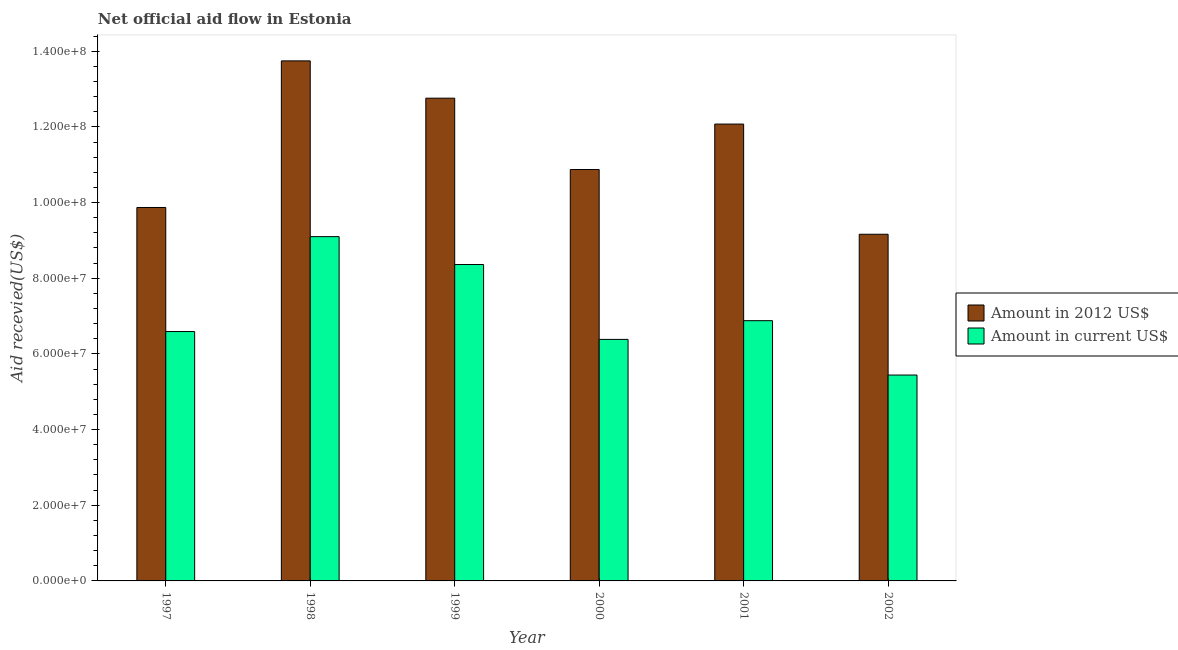How many groups of bars are there?
Offer a very short reply. 6. Are the number of bars on each tick of the X-axis equal?
Ensure brevity in your answer.  Yes. How many bars are there on the 1st tick from the right?
Your response must be concise. 2. What is the amount of aid received(expressed in 2012 us$) in 2002?
Make the answer very short. 9.16e+07. Across all years, what is the maximum amount of aid received(expressed in us$)?
Ensure brevity in your answer.  9.10e+07. Across all years, what is the minimum amount of aid received(expressed in 2012 us$)?
Ensure brevity in your answer.  9.16e+07. In which year was the amount of aid received(expressed in us$) maximum?
Provide a succinct answer. 1998. What is the total amount of aid received(expressed in 2012 us$) in the graph?
Offer a terse response. 6.85e+08. What is the difference between the amount of aid received(expressed in 2012 us$) in 2000 and that in 2001?
Offer a very short reply. -1.20e+07. What is the difference between the amount of aid received(expressed in 2012 us$) in 1997 and the amount of aid received(expressed in us$) in 2001?
Offer a very short reply. -2.20e+07. What is the average amount of aid received(expressed in 2012 us$) per year?
Your response must be concise. 1.14e+08. In how many years, is the amount of aid received(expressed in 2012 us$) greater than 112000000 US$?
Your answer should be compact. 3. What is the ratio of the amount of aid received(expressed in 2012 us$) in 1997 to that in 1999?
Provide a succinct answer. 0.77. Is the amount of aid received(expressed in 2012 us$) in 1999 less than that in 2002?
Give a very brief answer. No. Is the difference between the amount of aid received(expressed in us$) in 1999 and 2001 greater than the difference between the amount of aid received(expressed in 2012 us$) in 1999 and 2001?
Provide a short and direct response. No. What is the difference between the highest and the second highest amount of aid received(expressed in 2012 us$)?
Provide a succinct answer. 9.86e+06. What is the difference between the highest and the lowest amount of aid received(expressed in 2012 us$)?
Give a very brief answer. 4.58e+07. What does the 1st bar from the left in 2000 represents?
Your answer should be compact. Amount in 2012 US$. What does the 2nd bar from the right in 1997 represents?
Your response must be concise. Amount in 2012 US$. Are all the bars in the graph horizontal?
Your response must be concise. No. How many years are there in the graph?
Offer a terse response. 6. Are the values on the major ticks of Y-axis written in scientific E-notation?
Give a very brief answer. Yes. Does the graph contain any zero values?
Offer a terse response. No. What is the title of the graph?
Provide a short and direct response. Net official aid flow in Estonia. Does "Mobile cellular" appear as one of the legend labels in the graph?
Provide a short and direct response. No. What is the label or title of the Y-axis?
Ensure brevity in your answer.  Aid recevied(US$). What is the Aid recevied(US$) in Amount in 2012 US$ in 1997?
Make the answer very short. 9.87e+07. What is the Aid recevied(US$) in Amount in current US$ in 1997?
Ensure brevity in your answer.  6.59e+07. What is the Aid recevied(US$) of Amount in 2012 US$ in 1998?
Provide a succinct answer. 1.37e+08. What is the Aid recevied(US$) in Amount in current US$ in 1998?
Your answer should be compact. 9.10e+07. What is the Aid recevied(US$) in Amount in 2012 US$ in 1999?
Provide a short and direct response. 1.28e+08. What is the Aid recevied(US$) in Amount in current US$ in 1999?
Provide a succinct answer. 8.36e+07. What is the Aid recevied(US$) of Amount in 2012 US$ in 2000?
Your response must be concise. 1.09e+08. What is the Aid recevied(US$) in Amount in current US$ in 2000?
Provide a short and direct response. 6.38e+07. What is the Aid recevied(US$) in Amount in 2012 US$ in 2001?
Give a very brief answer. 1.21e+08. What is the Aid recevied(US$) in Amount in current US$ in 2001?
Your answer should be compact. 6.88e+07. What is the Aid recevied(US$) in Amount in 2012 US$ in 2002?
Your response must be concise. 9.16e+07. What is the Aid recevied(US$) of Amount in current US$ in 2002?
Give a very brief answer. 5.44e+07. Across all years, what is the maximum Aid recevied(US$) in Amount in 2012 US$?
Provide a short and direct response. 1.37e+08. Across all years, what is the maximum Aid recevied(US$) of Amount in current US$?
Your response must be concise. 9.10e+07. Across all years, what is the minimum Aid recevied(US$) of Amount in 2012 US$?
Offer a very short reply. 9.16e+07. Across all years, what is the minimum Aid recevied(US$) of Amount in current US$?
Provide a short and direct response. 5.44e+07. What is the total Aid recevied(US$) of Amount in 2012 US$ in the graph?
Provide a short and direct response. 6.85e+08. What is the total Aid recevied(US$) of Amount in current US$ in the graph?
Keep it short and to the point. 4.28e+08. What is the difference between the Aid recevied(US$) in Amount in 2012 US$ in 1997 and that in 1998?
Offer a very short reply. -3.88e+07. What is the difference between the Aid recevied(US$) of Amount in current US$ in 1997 and that in 1998?
Provide a short and direct response. -2.51e+07. What is the difference between the Aid recevied(US$) in Amount in 2012 US$ in 1997 and that in 1999?
Your response must be concise. -2.89e+07. What is the difference between the Aid recevied(US$) in Amount in current US$ in 1997 and that in 1999?
Keep it short and to the point. -1.77e+07. What is the difference between the Aid recevied(US$) in Amount in 2012 US$ in 1997 and that in 2000?
Offer a terse response. -1.00e+07. What is the difference between the Aid recevied(US$) in Amount in current US$ in 1997 and that in 2000?
Give a very brief answer. 2.08e+06. What is the difference between the Aid recevied(US$) of Amount in 2012 US$ in 1997 and that in 2001?
Offer a terse response. -2.20e+07. What is the difference between the Aid recevied(US$) in Amount in current US$ in 1997 and that in 2001?
Your answer should be compact. -2.87e+06. What is the difference between the Aid recevied(US$) in Amount in 2012 US$ in 1997 and that in 2002?
Ensure brevity in your answer.  7.07e+06. What is the difference between the Aid recevied(US$) in Amount in current US$ in 1997 and that in 2002?
Offer a terse response. 1.15e+07. What is the difference between the Aid recevied(US$) in Amount in 2012 US$ in 1998 and that in 1999?
Offer a terse response. 9.86e+06. What is the difference between the Aid recevied(US$) in Amount in current US$ in 1998 and that in 1999?
Your response must be concise. 7.37e+06. What is the difference between the Aid recevied(US$) of Amount in 2012 US$ in 1998 and that in 2000?
Provide a short and direct response. 2.87e+07. What is the difference between the Aid recevied(US$) of Amount in current US$ in 1998 and that in 2000?
Provide a succinct answer. 2.72e+07. What is the difference between the Aid recevied(US$) in Amount in 2012 US$ in 1998 and that in 2001?
Provide a succinct answer. 1.67e+07. What is the difference between the Aid recevied(US$) of Amount in current US$ in 1998 and that in 2001?
Keep it short and to the point. 2.22e+07. What is the difference between the Aid recevied(US$) of Amount in 2012 US$ in 1998 and that in 2002?
Make the answer very short. 4.58e+07. What is the difference between the Aid recevied(US$) in Amount in current US$ in 1998 and that in 2002?
Provide a succinct answer. 3.66e+07. What is the difference between the Aid recevied(US$) in Amount in 2012 US$ in 1999 and that in 2000?
Provide a succinct answer. 1.88e+07. What is the difference between the Aid recevied(US$) in Amount in current US$ in 1999 and that in 2000?
Ensure brevity in your answer.  1.98e+07. What is the difference between the Aid recevied(US$) of Amount in 2012 US$ in 1999 and that in 2001?
Your response must be concise. 6.84e+06. What is the difference between the Aid recevied(US$) in Amount in current US$ in 1999 and that in 2001?
Ensure brevity in your answer.  1.48e+07. What is the difference between the Aid recevied(US$) of Amount in 2012 US$ in 1999 and that in 2002?
Give a very brief answer. 3.60e+07. What is the difference between the Aid recevied(US$) in Amount in current US$ in 1999 and that in 2002?
Your response must be concise. 2.92e+07. What is the difference between the Aid recevied(US$) in Amount in 2012 US$ in 2000 and that in 2001?
Your response must be concise. -1.20e+07. What is the difference between the Aid recevied(US$) in Amount in current US$ in 2000 and that in 2001?
Provide a succinct answer. -4.95e+06. What is the difference between the Aid recevied(US$) in Amount in 2012 US$ in 2000 and that in 2002?
Give a very brief answer. 1.71e+07. What is the difference between the Aid recevied(US$) of Amount in current US$ in 2000 and that in 2002?
Offer a very short reply. 9.42e+06. What is the difference between the Aid recevied(US$) of Amount in 2012 US$ in 2001 and that in 2002?
Ensure brevity in your answer.  2.91e+07. What is the difference between the Aid recevied(US$) of Amount in current US$ in 2001 and that in 2002?
Keep it short and to the point. 1.44e+07. What is the difference between the Aid recevied(US$) of Amount in 2012 US$ in 1997 and the Aid recevied(US$) of Amount in current US$ in 1998?
Offer a terse response. 7.70e+06. What is the difference between the Aid recevied(US$) in Amount in 2012 US$ in 1997 and the Aid recevied(US$) in Amount in current US$ in 1999?
Your answer should be compact. 1.51e+07. What is the difference between the Aid recevied(US$) in Amount in 2012 US$ in 1997 and the Aid recevied(US$) in Amount in current US$ in 2000?
Keep it short and to the point. 3.49e+07. What is the difference between the Aid recevied(US$) in Amount in 2012 US$ in 1997 and the Aid recevied(US$) in Amount in current US$ in 2001?
Offer a very short reply. 2.99e+07. What is the difference between the Aid recevied(US$) in Amount in 2012 US$ in 1997 and the Aid recevied(US$) in Amount in current US$ in 2002?
Your response must be concise. 4.43e+07. What is the difference between the Aid recevied(US$) in Amount in 2012 US$ in 1998 and the Aid recevied(US$) in Amount in current US$ in 1999?
Keep it short and to the point. 5.38e+07. What is the difference between the Aid recevied(US$) of Amount in 2012 US$ in 1998 and the Aid recevied(US$) of Amount in current US$ in 2000?
Provide a short and direct response. 7.36e+07. What is the difference between the Aid recevied(US$) of Amount in 2012 US$ in 1998 and the Aid recevied(US$) of Amount in current US$ in 2001?
Your answer should be compact. 6.87e+07. What is the difference between the Aid recevied(US$) in Amount in 2012 US$ in 1998 and the Aid recevied(US$) in Amount in current US$ in 2002?
Offer a very short reply. 8.30e+07. What is the difference between the Aid recevied(US$) of Amount in 2012 US$ in 1999 and the Aid recevied(US$) of Amount in current US$ in 2000?
Your response must be concise. 6.38e+07. What is the difference between the Aid recevied(US$) of Amount in 2012 US$ in 1999 and the Aid recevied(US$) of Amount in current US$ in 2001?
Keep it short and to the point. 5.88e+07. What is the difference between the Aid recevied(US$) of Amount in 2012 US$ in 1999 and the Aid recevied(US$) of Amount in current US$ in 2002?
Ensure brevity in your answer.  7.32e+07. What is the difference between the Aid recevied(US$) of Amount in 2012 US$ in 2000 and the Aid recevied(US$) of Amount in current US$ in 2001?
Give a very brief answer. 4.00e+07. What is the difference between the Aid recevied(US$) of Amount in 2012 US$ in 2000 and the Aid recevied(US$) of Amount in current US$ in 2002?
Your answer should be compact. 5.43e+07. What is the difference between the Aid recevied(US$) in Amount in 2012 US$ in 2001 and the Aid recevied(US$) in Amount in current US$ in 2002?
Your answer should be very brief. 6.63e+07. What is the average Aid recevied(US$) of Amount in 2012 US$ per year?
Provide a short and direct response. 1.14e+08. What is the average Aid recevied(US$) of Amount in current US$ per year?
Give a very brief answer. 7.13e+07. In the year 1997, what is the difference between the Aid recevied(US$) of Amount in 2012 US$ and Aid recevied(US$) of Amount in current US$?
Offer a terse response. 3.28e+07. In the year 1998, what is the difference between the Aid recevied(US$) of Amount in 2012 US$ and Aid recevied(US$) of Amount in current US$?
Offer a very short reply. 4.64e+07. In the year 1999, what is the difference between the Aid recevied(US$) of Amount in 2012 US$ and Aid recevied(US$) of Amount in current US$?
Ensure brevity in your answer.  4.40e+07. In the year 2000, what is the difference between the Aid recevied(US$) in Amount in 2012 US$ and Aid recevied(US$) in Amount in current US$?
Offer a terse response. 4.49e+07. In the year 2001, what is the difference between the Aid recevied(US$) of Amount in 2012 US$ and Aid recevied(US$) of Amount in current US$?
Offer a very short reply. 5.20e+07. In the year 2002, what is the difference between the Aid recevied(US$) of Amount in 2012 US$ and Aid recevied(US$) of Amount in current US$?
Provide a succinct answer. 3.72e+07. What is the ratio of the Aid recevied(US$) in Amount in 2012 US$ in 1997 to that in 1998?
Offer a very short reply. 0.72. What is the ratio of the Aid recevied(US$) of Amount in current US$ in 1997 to that in 1998?
Offer a very short reply. 0.72. What is the ratio of the Aid recevied(US$) in Amount in 2012 US$ in 1997 to that in 1999?
Offer a terse response. 0.77. What is the ratio of the Aid recevied(US$) in Amount in current US$ in 1997 to that in 1999?
Ensure brevity in your answer.  0.79. What is the ratio of the Aid recevied(US$) in Amount in 2012 US$ in 1997 to that in 2000?
Make the answer very short. 0.91. What is the ratio of the Aid recevied(US$) of Amount in current US$ in 1997 to that in 2000?
Give a very brief answer. 1.03. What is the ratio of the Aid recevied(US$) of Amount in 2012 US$ in 1997 to that in 2001?
Ensure brevity in your answer.  0.82. What is the ratio of the Aid recevied(US$) of Amount in 2012 US$ in 1997 to that in 2002?
Offer a terse response. 1.08. What is the ratio of the Aid recevied(US$) of Amount in current US$ in 1997 to that in 2002?
Your response must be concise. 1.21. What is the ratio of the Aid recevied(US$) of Amount in 2012 US$ in 1998 to that in 1999?
Provide a short and direct response. 1.08. What is the ratio of the Aid recevied(US$) in Amount in current US$ in 1998 to that in 1999?
Make the answer very short. 1.09. What is the ratio of the Aid recevied(US$) in Amount in 2012 US$ in 1998 to that in 2000?
Offer a very short reply. 1.26. What is the ratio of the Aid recevied(US$) in Amount in current US$ in 1998 to that in 2000?
Your response must be concise. 1.43. What is the ratio of the Aid recevied(US$) of Amount in 2012 US$ in 1998 to that in 2001?
Your response must be concise. 1.14. What is the ratio of the Aid recevied(US$) of Amount in current US$ in 1998 to that in 2001?
Offer a very short reply. 1.32. What is the ratio of the Aid recevied(US$) of Amount in 2012 US$ in 1998 to that in 2002?
Offer a terse response. 1.5. What is the ratio of the Aid recevied(US$) of Amount in current US$ in 1998 to that in 2002?
Offer a very short reply. 1.67. What is the ratio of the Aid recevied(US$) in Amount in 2012 US$ in 1999 to that in 2000?
Your answer should be very brief. 1.17. What is the ratio of the Aid recevied(US$) of Amount in current US$ in 1999 to that in 2000?
Make the answer very short. 1.31. What is the ratio of the Aid recevied(US$) in Amount in 2012 US$ in 1999 to that in 2001?
Make the answer very short. 1.06. What is the ratio of the Aid recevied(US$) in Amount in current US$ in 1999 to that in 2001?
Provide a succinct answer. 1.22. What is the ratio of the Aid recevied(US$) of Amount in 2012 US$ in 1999 to that in 2002?
Your response must be concise. 1.39. What is the ratio of the Aid recevied(US$) in Amount in current US$ in 1999 to that in 2002?
Your response must be concise. 1.54. What is the ratio of the Aid recevied(US$) in Amount in 2012 US$ in 2000 to that in 2001?
Give a very brief answer. 0.9. What is the ratio of the Aid recevied(US$) in Amount in current US$ in 2000 to that in 2001?
Give a very brief answer. 0.93. What is the ratio of the Aid recevied(US$) in Amount in 2012 US$ in 2000 to that in 2002?
Offer a very short reply. 1.19. What is the ratio of the Aid recevied(US$) of Amount in current US$ in 2000 to that in 2002?
Offer a terse response. 1.17. What is the ratio of the Aid recevied(US$) of Amount in 2012 US$ in 2001 to that in 2002?
Offer a very short reply. 1.32. What is the ratio of the Aid recevied(US$) of Amount in current US$ in 2001 to that in 2002?
Your response must be concise. 1.26. What is the difference between the highest and the second highest Aid recevied(US$) in Amount in 2012 US$?
Make the answer very short. 9.86e+06. What is the difference between the highest and the second highest Aid recevied(US$) in Amount in current US$?
Offer a terse response. 7.37e+06. What is the difference between the highest and the lowest Aid recevied(US$) in Amount in 2012 US$?
Make the answer very short. 4.58e+07. What is the difference between the highest and the lowest Aid recevied(US$) in Amount in current US$?
Your answer should be compact. 3.66e+07. 